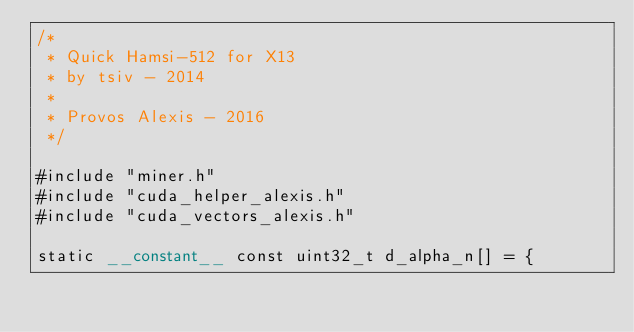Convert code to text. <code><loc_0><loc_0><loc_500><loc_500><_Cuda_>/*
 * Quick Hamsi-512 for X13
 * by tsiv - 2014
 *
 * Provos Alexis - 2016
 */

#include "miner.h"
#include "cuda_helper_alexis.h"
#include "cuda_vectors_alexis.h"

static __constant__ const uint32_t d_alpha_n[] = {</code> 